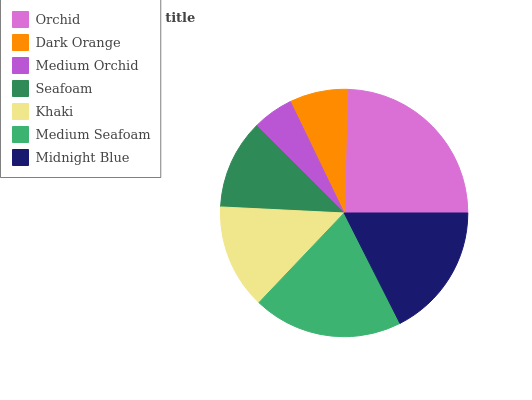Is Medium Orchid the minimum?
Answer yes or no. Yes. Is Orchid the maximum?
Answer yes or no. Yes. Is Dark Orange the minimum?
Answer yes or no. No. Is Dark Orange the maximum?
Answer yes or no. No. Is Orchid greater than Dark Orange?
Answer yes or no. Yes. Is Dark Orange less than Orchid?
Answer yes or no. Yes. Is Dark Orange greater than Orchid?
Answer yes or no. No. Is Orchid less than Dark Orange?
Answer yes or no. No. Is Khaki the high median?
Answer yes or no. Yes. Is Khaki the low median?
Answer yes or no. Yes. Is Orchid the high median?
Answer yes or no. No. Is Medium Orchid the low median?
Answer yes or no. No. 